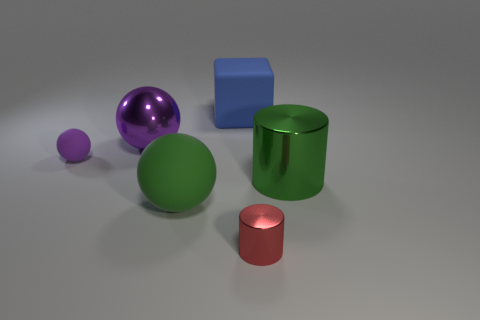Add 3 small rubber spheres. How many objects exist? 9 Subtract all cubes. How many objects are left? 5 Add 2 big green rubber objects. How many big green rubber objects exist? 3 Subtract 0 green blocks. How many objects are left? 6 Subtract all large objects. Subtract all green matte things. How many objects are left? 1 Add 5 green spheres. How many green spheres are left? 6 